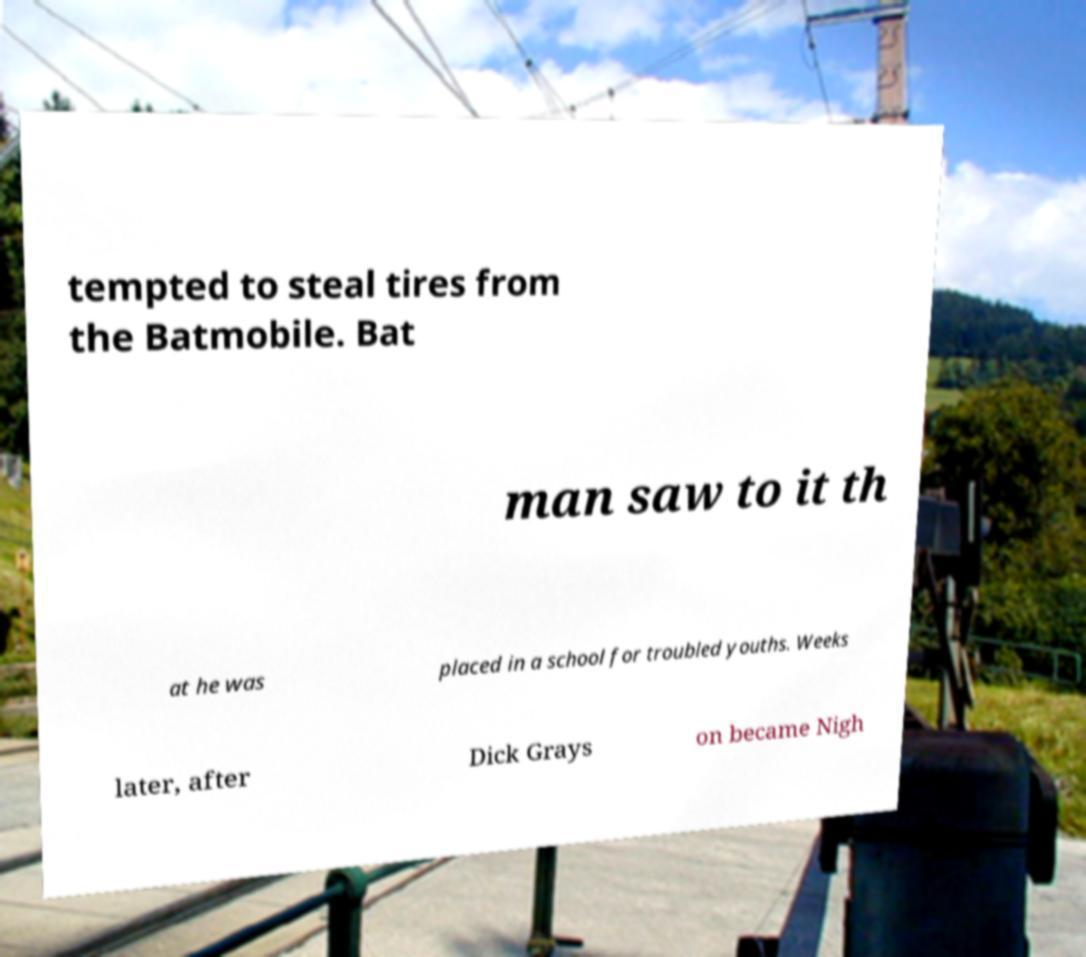Please identify and transcribe the text found in this image. tempted to steal tires from the Batmobile. Bat man saw to it th at he was placed in a school for troubled youths. Weeks later, after Dick Grays on became Nigh 